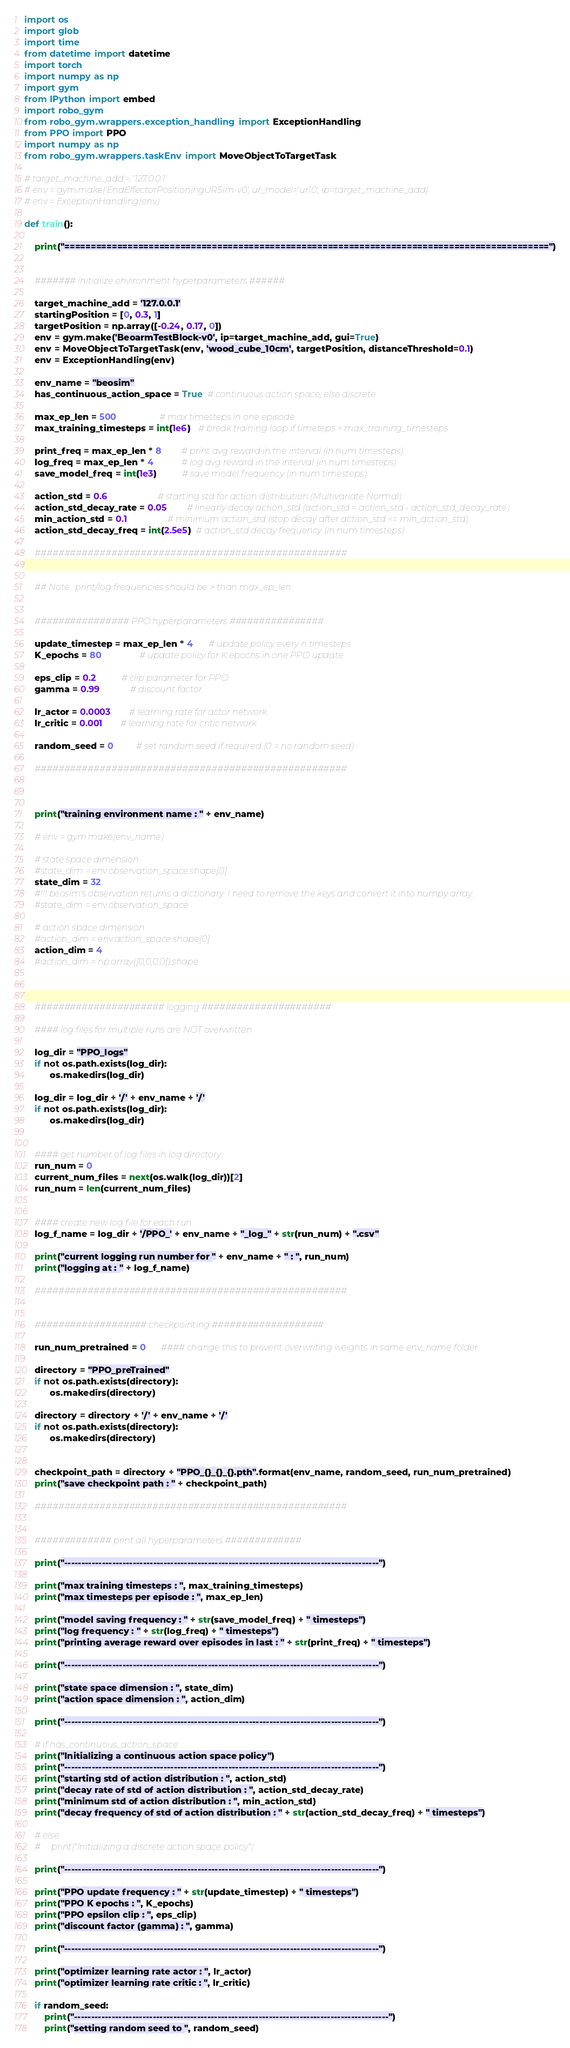<code> <loc_0><loc_0><loc_500><loc_500><_Python_>import os
import glob
import time
from datetime import datetime
import torch
import numpy as np
import gym
from IPython import embed
import robo_gym
from robo_gym.wrappers.exception_handling import ExceptionHandling
from PPO import PPO
import numpy as np
from robo_gym.wrappers.taskEnv import MoveObjectToTargetTask

# target_machine_add = '127.0.0.1'
# env = gym.make('EndEffectorPositioningURSim-v0', ur_model='ur10', ip=target_machine_add)
# env = ExceptionHandling(env)

def train():

    print("============================================================================================")


    ####### initialize environment hyperparameters ######

    target_machine_add = '127.0.0.1'
    startingPosition = [0, 0.3, 1]
    targetPosition = np.array([-0.24, 0.17, 0])
    env = gym.make('BeoarmTestBlock-v0', ip=target_machine_add, gui=True)
    env = MoveObjectToTargetTask(env, 'wood_cube_10cm', targetPosition, distanceThreshold=0.1)
    env = ExceptionHandling(env)

    env_name = "beosim"
    has_continuous_action_space = True  # continuous action space; else discrete

    max_ep_len = 500                 # max timesteps in one episode
    max_training_timesteps = int(1e6)   # break training loop if timeteps > max_training_timesteps

    print_freq = max_ep_len * 8        # print avg reward in the interval (in num timesteps)
    log_freq = max_ep_len * 4           # log avg reward in the interval (in num timesteps)
    save_model_freq = int(1e3)          # save model frequency (in num timesteps)

    action_std = 0.6                    # starting std for action distribution (Multivariate Normal)
    action_std_decay_rate = 0.05        # linearly decay action_std (action_std = action_std - action_std_decay_rate)
    min_action_std = 0.1                # minimum action_std (stop decay after action_std <= min_action_std)
    action_std_decay_freq = int(2.5e5)  # action_std decay frequency (in num timesteps)

    #####################################################


    ## Note : print/log frequencies should be > than max_ep_len


    ################ PPO hyperparameters ################

    update_timestep = max_ep_len * 4      # update policy every n timesteps
    K_epochs = 80               # update policy for K epochs in one PPO update

    eps_clip = 0.2          # clip parameter for PPO
    gamma = 0.99            # discount factor

    lr_actor = 0.0003       # learning rate for actor network
    lr_critic = 0.001       # learning rate for critic network

    random_seed = 0         # set random seed if required (0 = no random seed)

    #####################################################



    print("training environment name : " + env_name)

    # env = gym.make(env_name)

    # state space dimension
    #state_dim = env.observation_space.shape[0] 
    state_dim = 32
    #!!! beosim's observation returns a dictionary. I need to remove the keys and convert it into numpy array.
    #state_dim = env.observation_space

    # action space dimension
    #action_dim = env.action_space.shape[0]
    action_dim = 4
    #action_dim = np.array([0,0,0,0]).shape



    ###################### logging ######################

    #### log files for multiple runs are NOT overwritten

    log_dir = "PPO_logs"
    if not os.path.exists(log_dir):
          os.makedirs(log_dir)

    log_dir = log_dir + '/' + env_name + '/'
    if not os.path.exists(log_dir):
          os.makedirs(log_dir)


    #### get number of log files in log directory
    run_num = 0
    current_num_files = next(os.walk(log_dir))[2]
    run_num = len(current_num_files)


    #### create new log file for each run
    log_f_name = log_dir + '/PPO_' + env_name + "_log_" + str(run_num) + ".csv"

    print("current logging run number for " + env_name + " : ", run_num)
    print("logging at : " + log_f_name)

    #####################################################


    ################### checkpointing ###################

    run_num_pretrained = 0      #### change this to prevent overwriting weights in same env_name folder

    directory = "PPO_preTrained"
    if not os.path.exists(directory):
          os.makedirs(directory)

    directory = directory + '/' + env_name + '/'
    if not os.path.exists(directory):
          os.makedirs(directory)


    checkpoint_path = directory + "PPO_{}_{}_{}.pth".format(env_name, random_seed, run_num_pretrained)
    print("save checkpoint path : " + checkpoint_path)

    #####################################################


    ############# print all hyperparameters #############

    print("--------------------------------------------------------------------------------------------")

    print("max training timesteps : ", max_training_timesteps)
    print("max timesteps per episode : ", max_ep_len)

    print("model saving frequency : " + str(save_model_freq) + " timesteps")
    print("log frequency : " + str(log_freq) + " timesteps")
    print("printing average reward over episodes in last : " + str(print_freq) + " timesteps")

    print("--------------------------------------------------------------------------------------------")

    print("state space dimension : ", state_dim)
    print("action space dimension : ", action_dim)

    print("--------------------------------------------------------------------------------------------")

    # if has_continuous_action_space:
    print("Initializing a continuous action space policy")
    print("--------------------------------------------------------------------------------------------")
    print("starting std of action distribution : ", action_std)
    print("decay rate of std of action distribution : ", action_std_decay_rate)
    print("minimum std of action distribution : ", min_action_std)
    print("decay frequency of std of action distribution : " + str(action_std_decay_freq) + " timesteps")

    # else:
    #     print("Initializing a discrete action space policy")

    print("--------------------------------------------------------------------------------------------")

    print("PPO update frequency : " + str(update_timestep) + " timesteps")
    print("PPO K epochs : ", K_epochs)
    print("PPO epsilon clip : ", eps_clip)
    print("discount factor (gamma) : ", gamma)

    print("--------------------------------------------------------------------------------------------")

    print("optimizer learning rate actor : ", lr_actor)
    print("optimizer learning rate critic : ", lr_critic)

    if random_seed:
        print("--------------------------------------------------------------------------------------------")
        print("setting random seed to ", random_seed)</code> 